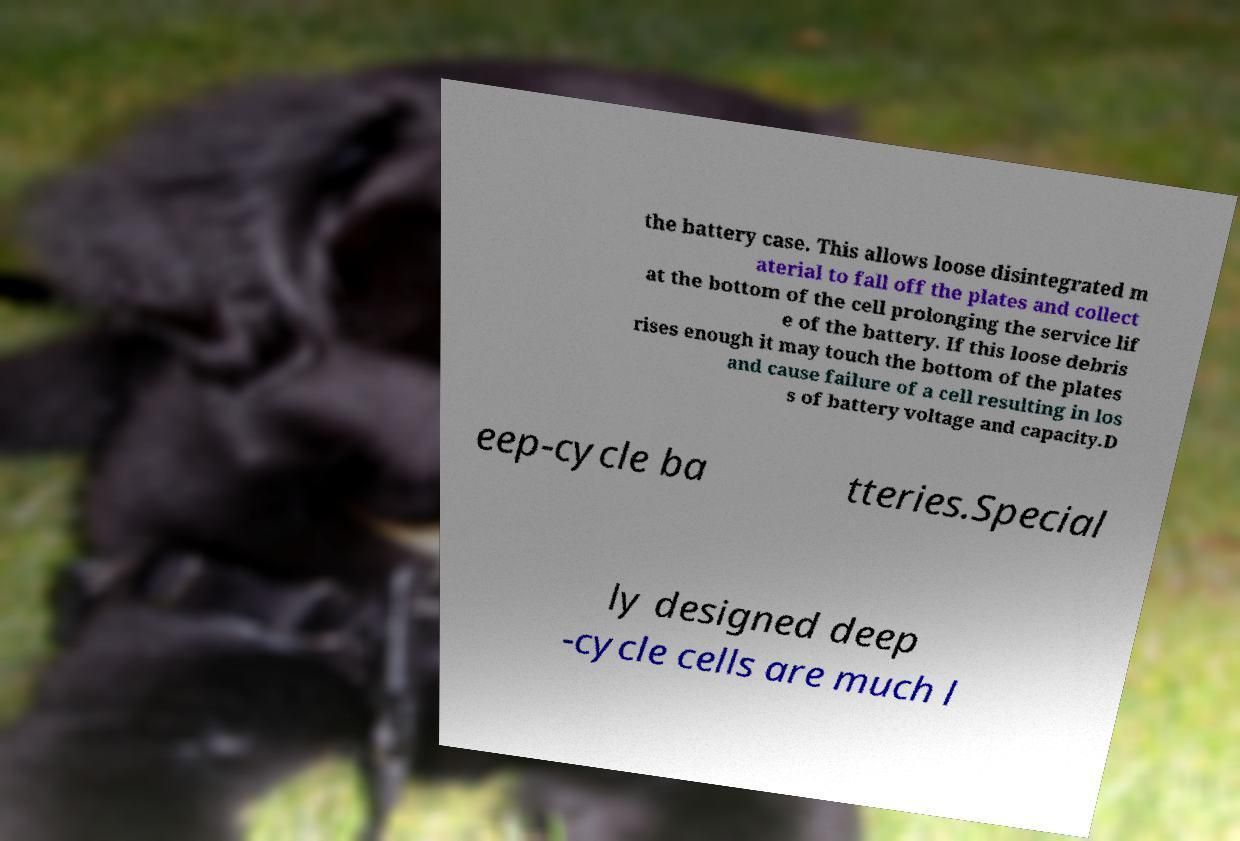There's text embedded in this image that I need extracted. Can you transcribe it verbatim? the battery case. This allows loose disintegrated m aterial to fall off the plates and collect at the bottom of the cell prolonging the service lif e of the battery. If this loose debris rises enough it may touch the bottom of the plates and cause failure of a cell resulting in los s of battery voltage and capacity.D eep-cycle ba tteries.Special ly designed deep -cycle cells are much l 